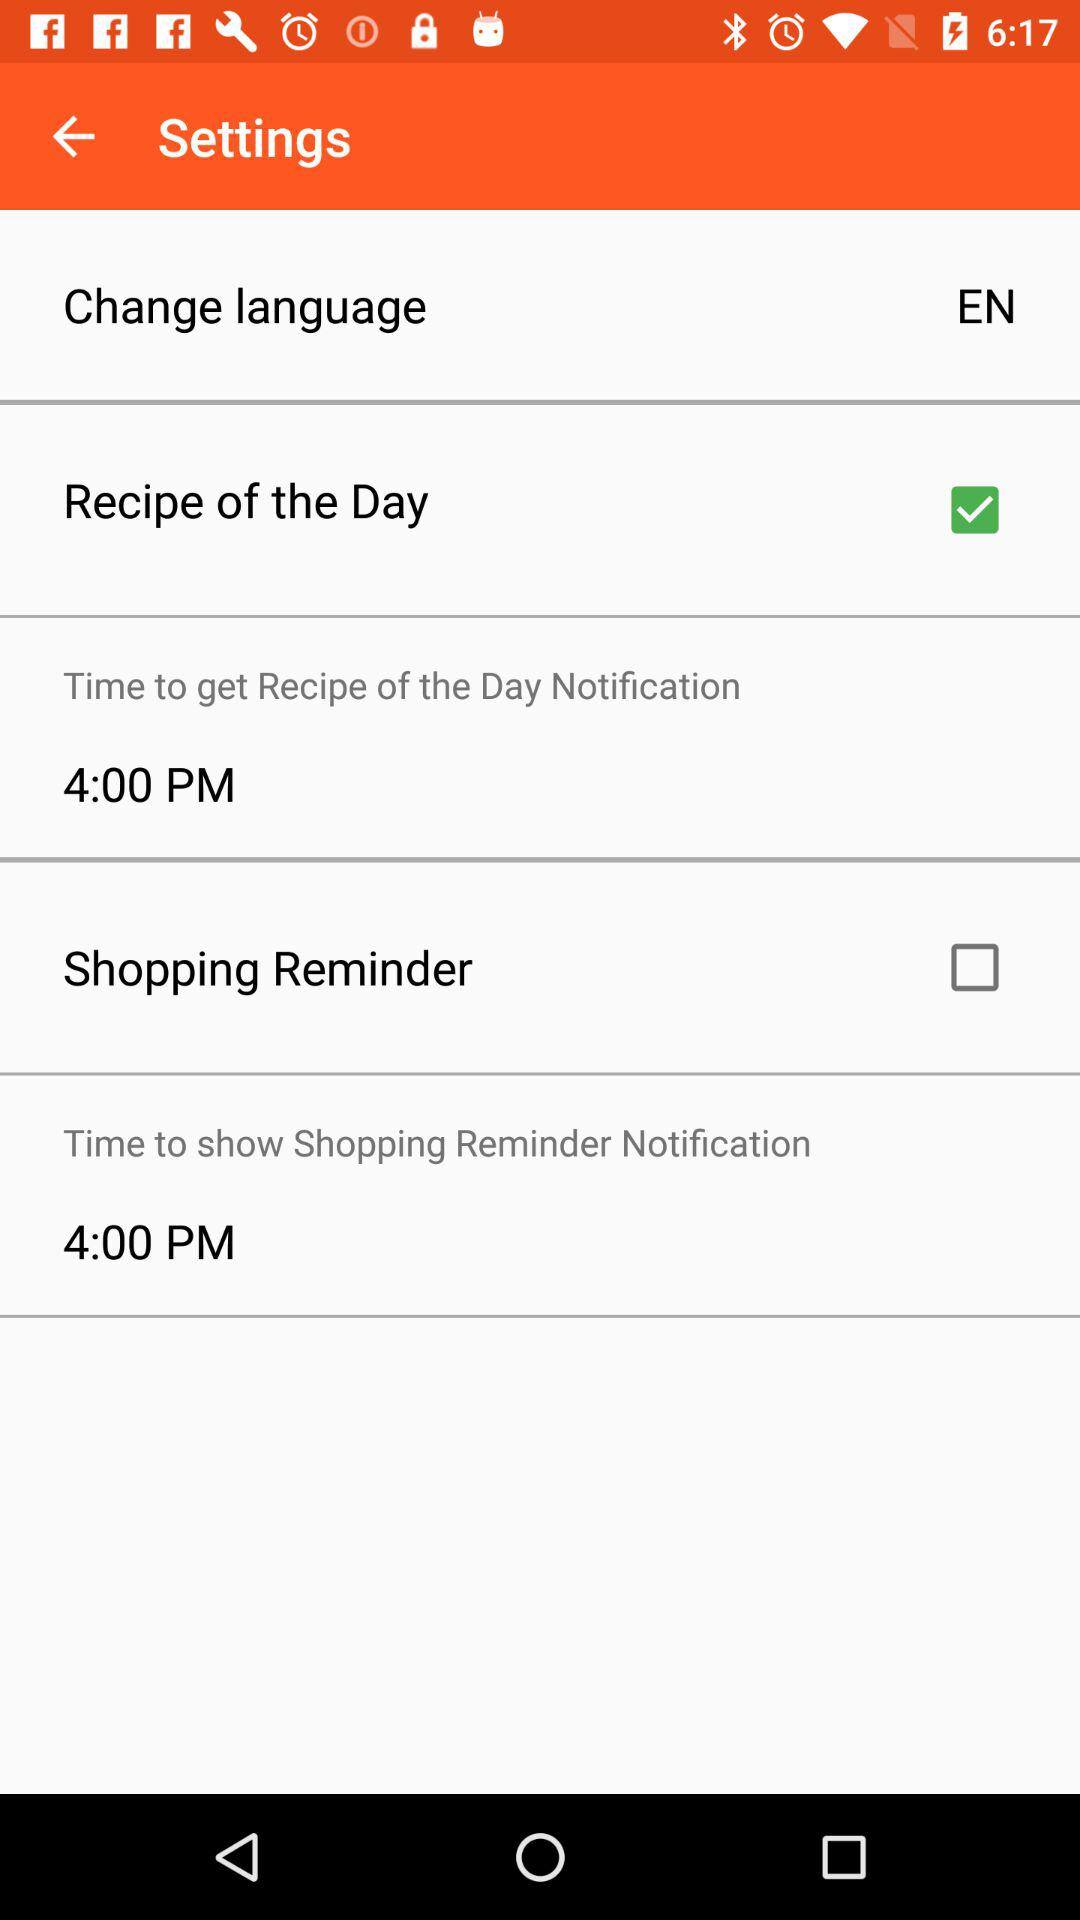What is the status of the "Shopping Reminder"? The status is "off". 